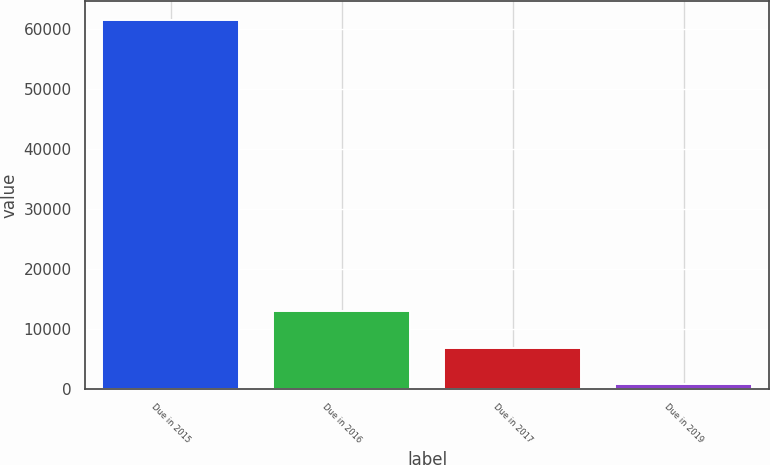Convert chart to OTSL. <chart><loc_0><loc_0><loc_500><loc_500><bar_chart><fcel>Due in 2015<fcel>Due in 2016<fcel>Due in 2017<fcel>Due in 2019<nl><fcel>61439<fcel>12951.8<fcel>6890.9<fcel>830<nl></chart> 